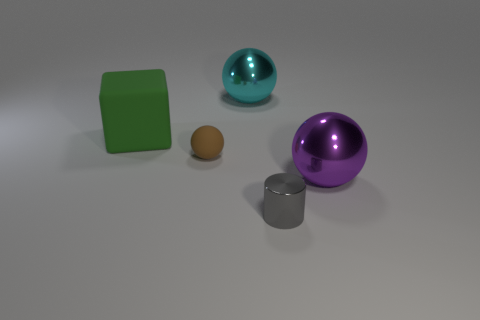Can you tell me the colors of all the objects present? Certainly, the colors of the objects are as follows: the large ball is cyan, the small rubber object is brown, the cube is green, the cylinder is silver, and the other ball is purple. 